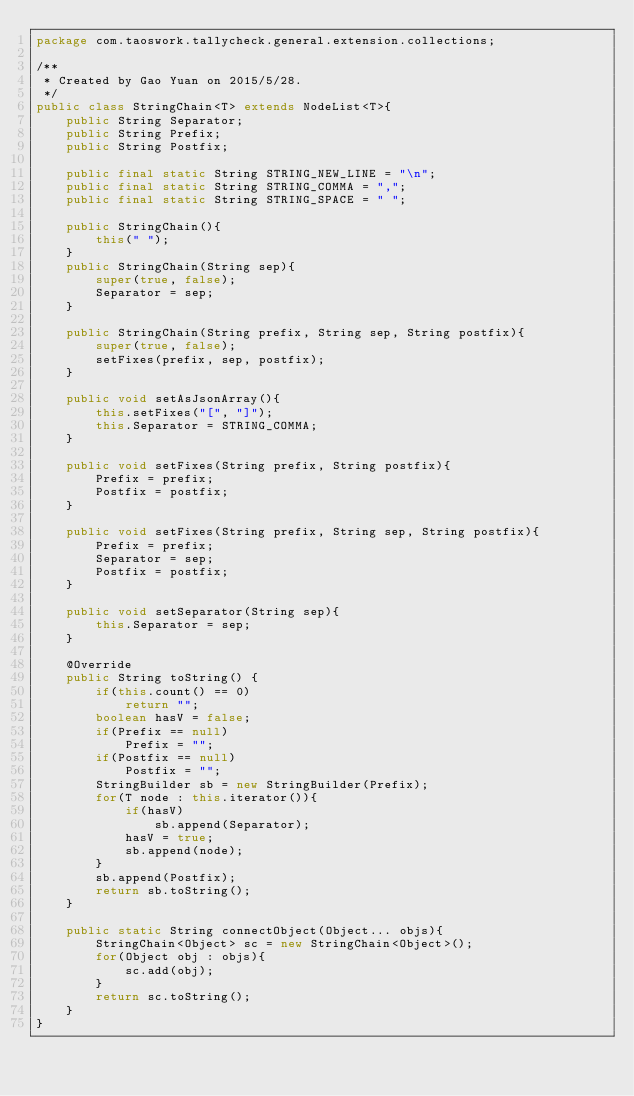Convert code to text. <code><loc_0><loc_0><loc_500><loc_500><_Java_>package com.taoswork.tallycheck.general.extension.collections;

/**
 * Created by Gao Yuan on 2015/5/28.
 */
public class StringChain<T> extends NodeList<T>{
    public String Separator;
    public String Prefix;
    public String Postfix;

    public final static String STRING_NEW_LINE = "\n";
    public final static String STRING_COMMA = ",";
    public final static String STRING_SPACE = " ";

    public StringChain(){
        this(" ");
    }
    public StringChain(String sep){
        super(true, false);
        Separator = sep;
    }

    public StringChain(String prefix, String sep, String postfix){
        super(true, false);
        setFixes(prefix, sep, postfix);
    }

    public void setAsJsonArray(){
        this.setFixes("[", "]");
        this.Separator = STRING_COMMA;
    }

    public void setFixes(String prefix, String postfix){
        Prefix = prefix;
        Postfix = postfix;
    }

    public void setFixes(String prefix, String sep, String postfix){
        Prefix = prefix;
        Separator = sep;
        Postfix = postfix;
    }

    public void setSeparator(String sep){
        this.Separator = sep;
    }

    @Override
    public String toString() {
        if(this.count() == 0)
            return "";
        boolean hasV = false;
        if(Prefix == null)
            Prefix = "";
        if(Postfix == null)
            Postfix = "";
        StringBuilder sb = new StringBuilder(Prefix);
        for(T node : this.iterator()){
            if(hasV)
                sb.append(Separator);
            hasV = true;
            sb.append(node);
        }
        sb.append(Postfix);
        return sb.toString();
    }

    public static String connectObject(Object... objs){
        StringChain<Object> sc = new StringChain<Object>();
        for(Object obj : objs){
            sc.add(obj);
        }
        return sc.toString();
    }
}
</code> 